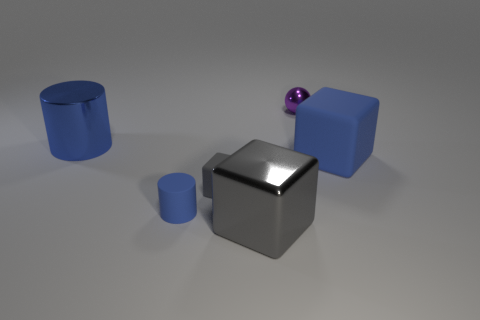Subtract all tiny gray blocks. How many blocks are left? 2 Subtract all blue blocks. How many blocks are left? 2 Add 4 blue rubber objects. How many blue rubber objects exist? 6 Add 1 tiny blue things. How many objects exist? 7 Subtract 0 brown cylinders. How many objects are left? 6 Subtract all cylinders. How many objects are left? 4 Subtract 1 cylinders. How many cylinders are left? 1 Subtract all brown cubes. Subtract all yellow cylinders. How many cubes are left? 3 Subtract all blue cylinders. How many blue spheres are left? 0 Subtract all gray blocks. Subtract all tiny objects. How many objects are left? 1 